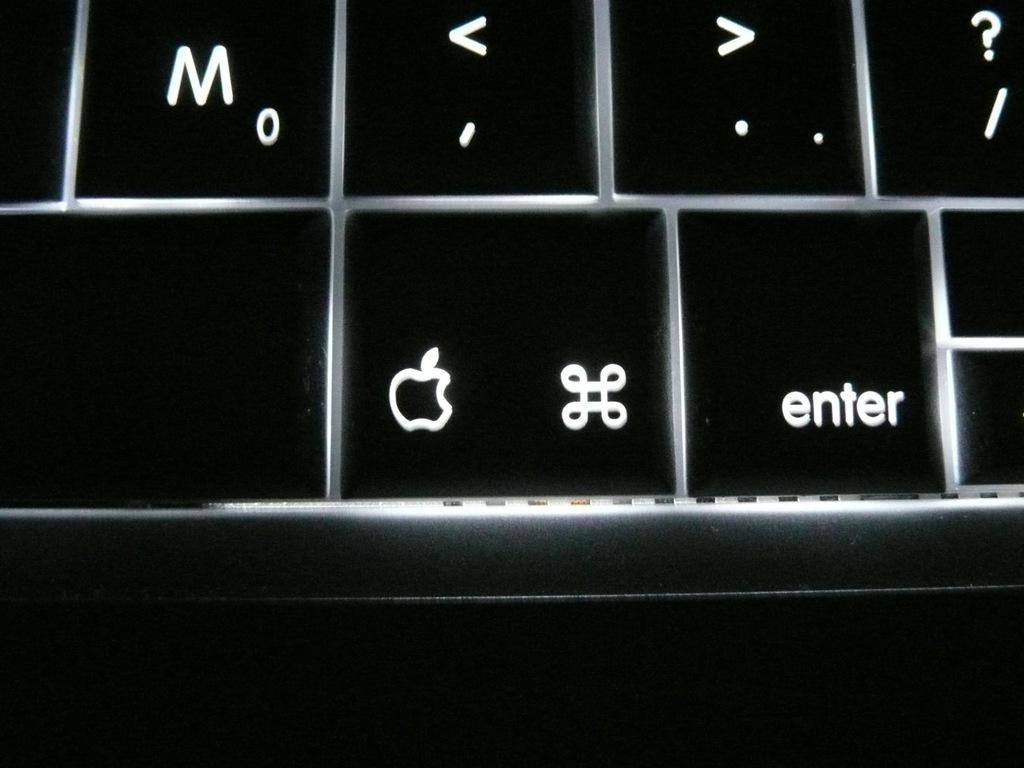Provide a one-sentence caption for the provided image. A picture of a keyboard with the enter key visible. 